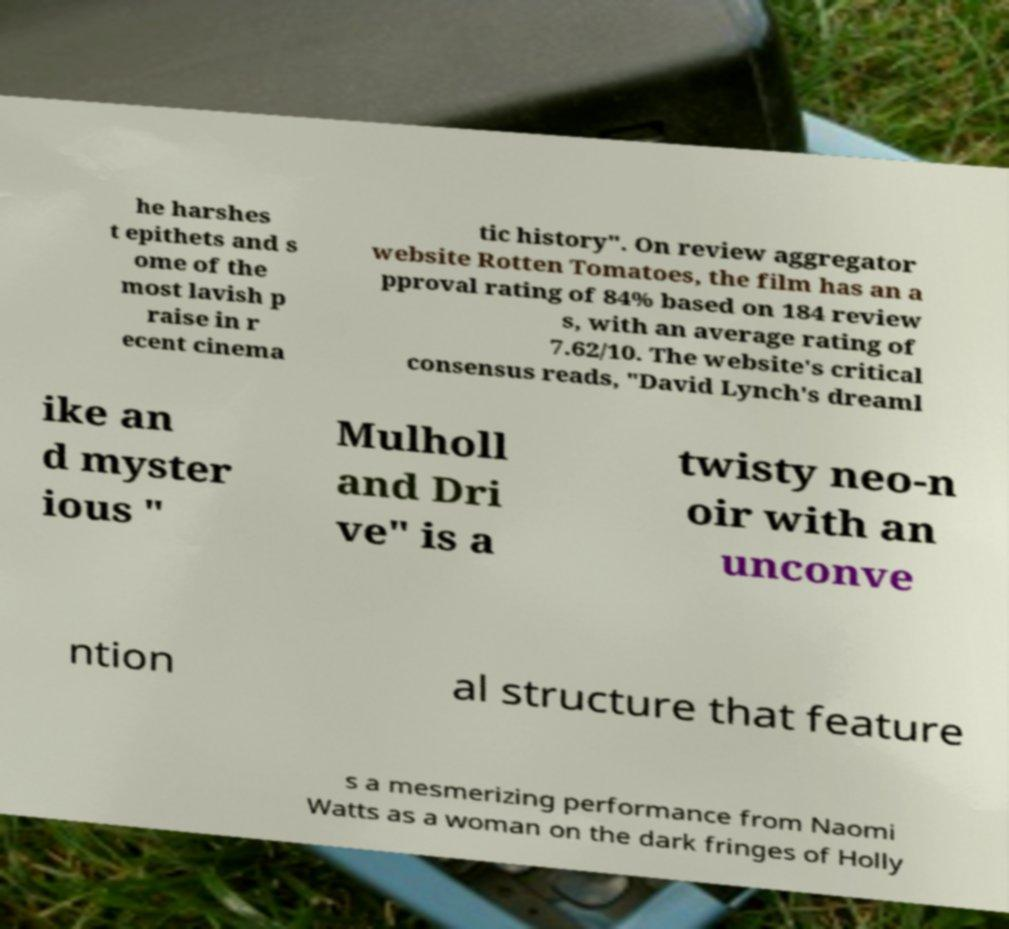I need the written content from this picture converted into text. Can you do that? he harshes t epithets and s ome of the most lavish p raise in r ecent cinema tic history". On review aggregator website Rotten Tomatoes, the film has an a pproval rating of 84% based on 184 review s, with an average rating of 7.62/10. The website's critical consensus reads, "David Lynch's dreaml ike an d myster ious " Mulholl and Dri ve" is a twisty neo-n oir with an unconve ntion al structure that feature s a mesmerizing performance from Naomi Watts as a woman on the dark fringes of Holly 